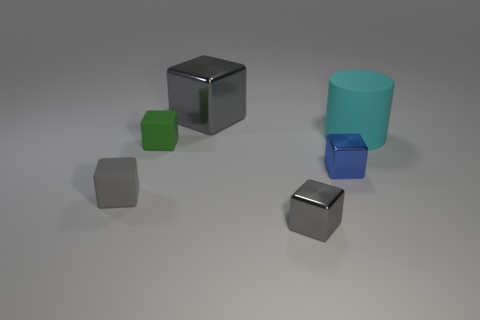What number of objects are either gray cylinders or green blocks?
Provide a short and direct response. 1. What is the size of the rubber block that is the same color as the big metallic thing?
Give a very brief answer. Small. There is a green matte block; are there any cubes in front of it?
Give a very brief answer. Yes. Are there more cyan matte objects that are on the right side of the big cyan thing than big cylinders left of the large gray metal block?
Your answer should be very brief. No. What is the size of the green object that is the same shape as the tiny blue object?
Provide a succinct answer. Small. How many balls are either green things or gray metallic objects?
Your answer should be compact. 0. Is the number of green matte cubes in front of the small gray rubber object less than the number of gray metal things behind the tiny green block?
Your answer should be compact. Yes. How many things are either small metallic blocks that are in front of the large cube or large gray things?
Your answer should be compact. 3. What is the shape of the small metal object behind the matte object that is left of the green rubber thing?
Make the answer very short. Cube. Are there any purple metallic objects of the same size as the cyan matte cylinder?
Give a very brief answer. No. 